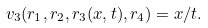<formula> <loc_0><loc_0><loc_500><loc_500>v _ { 3 } ( r _ { 1 } , r _ { 2 } , r _ { 3 } ( x , t ) , r _ { 4 } ) = x / t .</formula> 